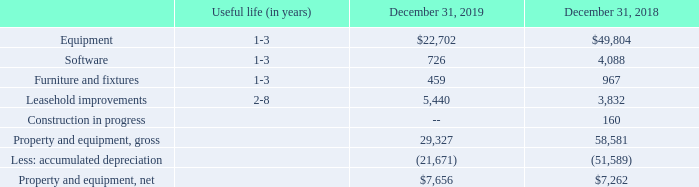Property and Equipment, Net
Property and equipment, net, consisted of the following (in thousands):
Depreciation expense on property and equipment was $5.0 million, $6.4 million and $7.1 million for the years
ended December 31, 2019, 2018 and 2017, respectively
What is the depreciation expense on property and equipment as at December 31, 2017? 
Answer scale should be: million. $7.1. What is the depreciation expense on property and equipment as at December 31, 2018?
Answer scale should be: million. $6.4. What is the depreciation expense on property and equipment as at December 31, 2019?
Answer scale should be: million. $5.0. What is the ratio of net property and equipment in 2019?
Answer scale should be: percent. 7,656 thousand /(7,656 thousand + $5 million) 
Answer: 60.49. What is the total depreciation expense on property and equipment from 2017 to 2019?
Answer scale should be: million. 5.0+6.4+7.1
Answer: 18.5. What is the total software value as at December 31, 2018 and 2019?
Answer scale should be: thousand. 726 + 4,088 
Answer: 4814. 